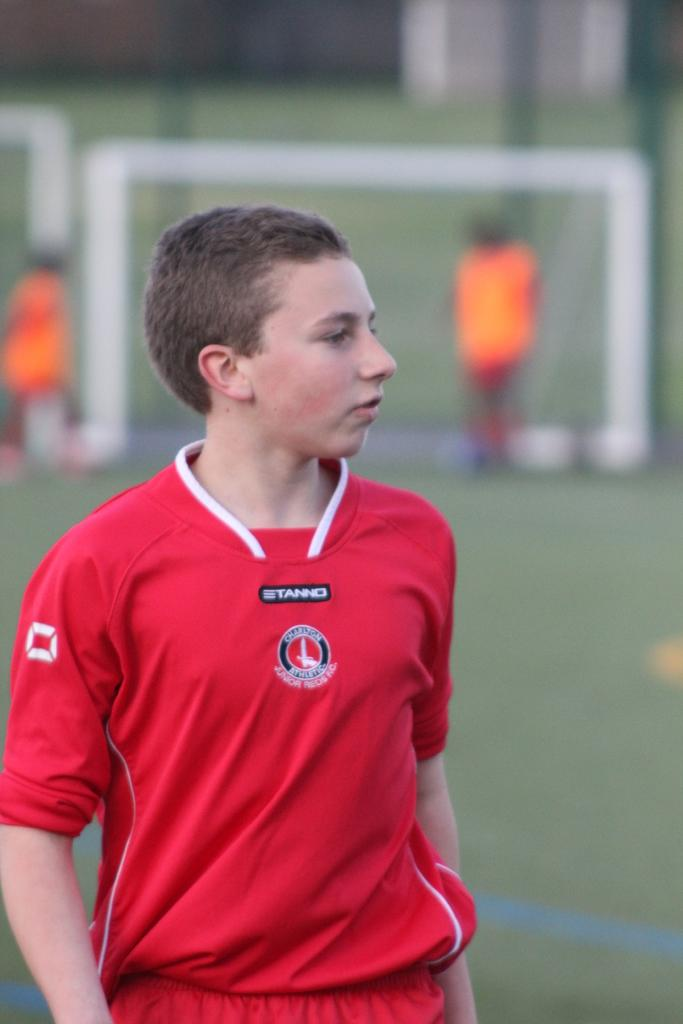Who is the main subject in the image? There is a boy in the image. What is the boy's location in the image? The boy is standing on a grass field. What can be seen in the background of the image? There are people and a golf post in the background of the image. How many guns can be seen in the image? There are no guns present in the image. What type of seashore can be seen in the image? There is no seashore present in the image; it features a boy standing on a grass field with people and a golf post in the background. 